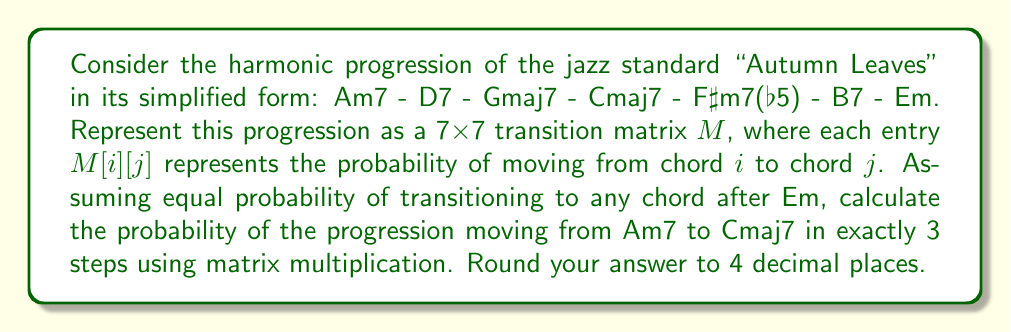Solve this math problem. 1) First, let's create the transition matrix M:

$$
M = \begin{bmatrix}
0 & 1 & 0 & 0 & 0 & 0 & 0 \\
0 & 0 & 1 & 0 & 0 & 0 & 0 \\
0 & 0 & 0 & 1 & 0 & 0 & 0 \\
0 & 0 & 0 & 0 & 1 & 0 & 0 \\
0 & 0 & 0 & 0 & 0 & 1 & 0 \\
0 & 0 & 0 & 0 & 0 & 0 & 1 \\
\frac{1}{7} & \frac{1}{7} & \frac{1}{7} & \frac{1}{7} & \frac{1}{7} & \frac{1}{7} & \frac{1}{7}
\end{bmatrix}
$$

2) To find the probability of moving from Am7 to Cmaj7 in exactly 3 steps, we need to calculate $M^3[1,4]$ (since Am7 is the 1st chord and Cmaj7 is the 4th chord in our ordering).

3) Let's compute $M^3$:

$$
M^3 = \begin{bmatrix}
0 & 0 & 1 & 0 & 0 & 0 & 0 \\
0 & 0 & 0 & 1 & 0 & 0 & 0 \\
0 & 0 & 0 & 0 & 1 & 0 & 0 \\
0 & 0 & 0 & 0 & 0 & 1 & 0 \\
0 & 0 & 0 & 0 & 0 & 0 & 1 \\
\frac{1}{7} & \frac{1}{7} & \frac{1}{7} & \frac{1}{7} & \frac{1}{7} & \frac{1}{7} & \frac{1}{7} \\
\frac{1}{7} & \frac{1}{7} & \frac{1}{7} & \frac{1}{7} & \frac{1}{7} & \frac{1}{7} & \frac{1}{7}
\end{bmatrix}
$$

4) The probability we're looking for is $M^3[1,4] = 0$.

5) Rounding to 4 decimal places: 0.0000
Answer: 0.0000 